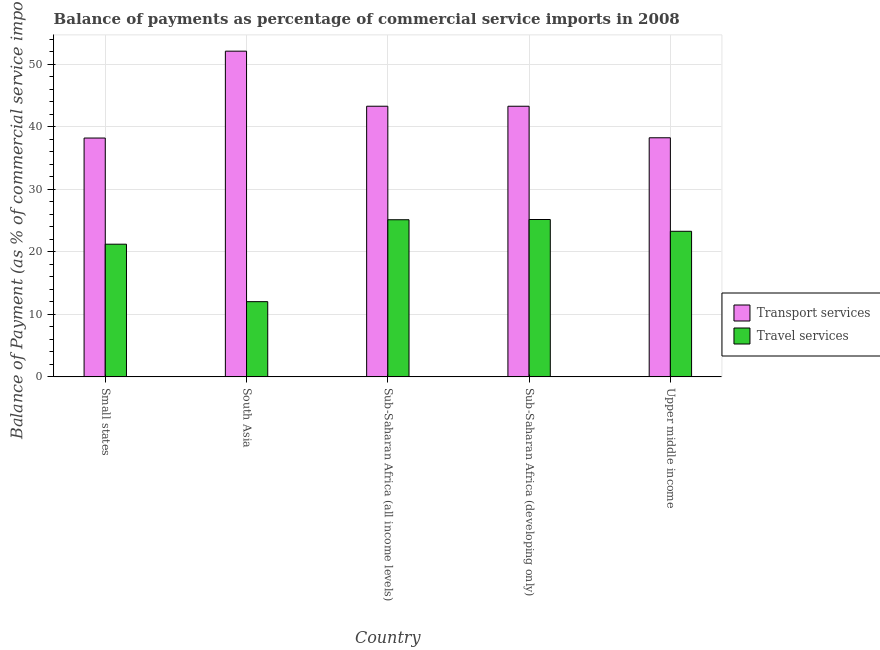How many different coloured bars are there?
Offer a terse response. 2. How many groups of bars are there?
Provide a succinct answer. 5. How many bars are there on the 1st tick from the left?
Provide a succinct answer. 2. What is the label of the 1st group of bars from the left?
Offer a very short reply. Small states. What is the balance of payments of travel services in Small states?
Your response must be concise. 21.23. Across all countries, what is the maximum balance of payments of transport services?
Your answer should be compact. 52.12. Across all countries, what is the minimum balance of payments of travel services?
Provide a short and direct response. 12.04. In which country was the balance of payments of transport services minimum?
Your answer should be very brief. Small states. What is the total balance of payments of travel services in the graph?
Ensure brevity in your answer.  106.89. What is the difference between the balance of payments of travel services in South Asia and that in Sub-Saharan Africa (all income levels)?
Offer a very short reply. -13.11. What is the difference between the balance of payments of travel services in Upper middle income and the balance of payments of transport services in South Asia?
Keep it short and to the point. -28.83. What is the average balance of payments of transport services per country?
Give a very brief answer. 43.04. What is the difference between the balance of payments of travel services and balance of payments of transport services in Sub-Saharan Africa (all income levels)?
Your response must be concise. -18.16. In how many countries, is the balance of payments of transport services greater than 30 %?
Give a very brief answer. 5. What is the ratio of the balance of payments of transport services in Sub-Saharan Africa (developing only) to that in Upper middle income?
Your answer should be very brief. 1.13. Is the difference between the balance of payments of travel services in South Asia and Sub-Saharan Africa (developing only) greater than the difference between the balance of payments of transport services in South Asia and Sub-Saharan Africa (developing only)?
Give a very brief answer. No. What is the difference between the highest and the second highest balance of payments of travel services?
Offer a very short reply. 0.04. What is the difference between the highest and the lowest balance of payments of travel services?
Provide a short and direct response. 13.15. In how many countries, is the balance of payments of transport services greater than the average balance of payments of transport services taken over all countries?
Give a very brief answer. 3. What does the 2nd bar from the left in Small states represents?
Provide a short and direct response. Travel services. What does the 2nd bar from the right in Sub-Saharan Africa (developing only) represents?
Keep it short and to the point. Transport services. Are all the bars in the graph horizontal?
Offer a very short reply. No. Are the values on the major ticks of Y-axis written in scientific E-notation?
Give a very brief answer. No. Does the graph contain any zero values?
Make the answer very short. No. Does the graph contain grids?
Keep it short and to the point. Yes. How many legend labels are there?
Provide a succinct answer. 2. What is the title of the graph?
Provide a succinct answer. Balance of payments as percentage of commercial service imports in 2008. What is the label or title of the X-axis?
Make the answer very short. Country. What is the label or title of the Y-axis?
Offer a very short reply. Balance of Payment (as % of commercial service imports). What is the Balance of Payment (as % of commercial service imports) of Transport services in Small states?
Your response must be concise. 38.22. What is the Balance of Payment (as % of commercial service imports) in Travel services in Small states?
Offer a very short reply. 21.23. What is the Balance of Payment (as % of commercial service imports) in Transport services in South Asia?
Your response must be concise. 52.12. What is the Balance of Payment (as % of commercial service imports) in Travel services in South Asia?
Offer a terse response. 12.04. What is the Balance of Payment (as % of commercial service imports) of Transport services in Sub-Saharan Africa (all income levels)?
Offer a terse response. 43.31. What is the Balance of Payment (as % of commercial service imports) in Travel services in Sub-Saharan Africa (all income levels)?
Provide a short and direct response. 25.15. What is the Balance of Payment (as % of commercial service imports) of Transport services in Sub-Saharan Africa (developing only)?
Your response must be concise. 43.31. What is the Balance of Payment (as % of commercial service imports) of Travel services in Sub-Saharan Africa (developing only)?
Your answer should be very brief. 25.18. What is the Balance of Payment (as % of commercial service imports) of Transport services in Upper middle income?
Your answer should be compact. 38.26. What is the Balance of Payment (as % of commercial service imports) in Travel services in Upper middle income?
Your response must be concise. 23.3. Across all countries, what is the maximum Balance of Payment (as % of commercial service imports) in Transport services?
Offer a terse response. 52.12. Across all countries, what is the maximum Balance of Payment (as % of commercial service imports) in Travel services?
Provide a succinct answer. 25.18. Across all countries, what is the minimum Balance of Payment (as % of commercial service imports) of Transport services?
Give a very brief answer. 38.22. Across all countries, what is the minimum Balance of Payment (as % of commercial service imports) in Travel services?
Make the answer very short. 12.04. What is the total Balance of Payment (as % of commercial service imports) in Transport services in the graph?
Give a very brief answer. 215.22. What is the total Balance of Payment (as % of commercial service imports) in Travel services in the graph?
Make the answer very short. 106.89. What is the difference between the Balance of Payment (as % of commercial service imports) of Transport services in Small states and that in South Asia?
Your answer should be compact. -13.9. What is the difference between the Balance of Payment (as % of commercial service imports) of Travel services in Small states and that in South Asia?
Provide a succinct answer. 9.2. What is the difference between the Balance of Payment (as % of commercial service imports) in Transport services in Small states and that in Sub-Saharan Africa (all income levels)?
Your answer should be very brief. -5.09. What is the difference between the Balance of Payment (as % of commercial service imports) of Travel services in Small states and that in Sub-Saharan Africa (all income levels)?
Your response must be concise. -3.91. What is the difference between the Balance of Payment (as % of commercial service imports) in Transport services in Small states and that in Sub-Saharan Africa (developing only)?
Provide a short and direct response. -5.09. What is the difference between the Balance of Payment (as % of commercial service imports) of Travel services in Small states and that in Sub-Saharan Africa (developing only)?
Ensure brevity in your answer.  -3.95. What is the difference between the Balance of Payment (as % of commercial service imports) of Transport services in Small states and that in Upper middle income?
Your response must be concise. -0.04. What is the difference between the Balance of Payment (as % of commercial service imports) of Travel services in Small states and that in Upper middle income?
Offer a very short reply. -2.06. What is the difference between the Balance of Payment (as % of commercial service imports) of Transport services in South Asia and that in Sub-Saharan Africa (all income levels)?
Your answer should be very brief. 8.81. What is the difference between the Balance of Payment (as % of commercial service imports) of Travel services in South Asia and that in Sub-Saharan Africa (all income levels)?
Offer a terse response. -13.11. What is the difference between the Balance of Payment (as % of commercial service imports) in Transport services in South Asia and that in Sub-Saharan Africa (developing only)?
Ensure brevity in your answer.  8.81. What is the difference between the Balance of Payment (as % of commercial service imports) of Travel services in South Asia and that in Sub-Saharan Africa (developing only)?
Provide a succinct answer. -13.15. What is the difference between the Balance of Payment (as % of commercial service imports) in Transport services in South Asia and that in Upper middle income?
Provide a succinct answer. 13.86. What is the difference between the Balance of Payment (as % of commercial service imports) of Travel services in South Asia and that in Upper middle income?
Keep it short and to the point. -11.26. What is the difference between the Balance of Payment (as % of commercial service imports) of Transport services in Sub-Saharan Africa (all income levels) and that in Sub-Saharan Africa (developing only)?
Make the answer very short. 0. What is the difference between the Balance of Payment (as % of commercial service imports) of Travel services in Sub-Saharan Africa (all income levels) and that in Sub-Saharan Africa (developing only)?
Offer a very short reply. -0.04. What is the difference between the Balance of Payment (as % of commercial service imports) of Transport services in Sub-Saharan Africa (all income levels) and that in Upper middle income?
Provide a short and direct response. 5.05. What is the difference between the Balance of Payment (as % of commercial service imports) in Travel services in Sub-Saharan Africa (all income levels) and that in Upper middle income?
Provide a succinct answer. 1.85. What is the difference between the Balance of Payment (as % of commercial service imports) in Transport services in Sub-Saharan Africa (developing only) and that in Upper middle income?
Your response must be concise. 5.05. What is the difference between the Balance of Payment (as % of commercial service imports) of Travel services in Sub-Saharan Africa (developing only) and that in Upper middle income?
Provide a short and direct response. 1.89. What is the difference between the Balance of Payment (as % of commercial service imports) of Transport services in Small states and the Balance of Payment (as % of commercial service imports) of Travel services in South Asia?
Your answer should be very brief. 26.18. What is the difference between the Balance of Payment (as % of commercial service imports) of Transport services in Small states and the Balance of Payment (as % of commercial service imports) of Travel services in Sub-Saharan Africa (all income levels)?
Make the answer very short. 13.07. What is the difference between the Balance of Payment (as % of commercial service imports) in Transport services in Small states and the Balance of Payment (as % of commercial service imports) in Travel services in Sub-Saharan Africa (developing only)?
Keep it short and to the point. 13.04. What is the difference between the Balance of Payment (as % of commercial service imports) in Transport services in Small states and the Balance of Payment (as % of commercial service imports) in Travel services in Upper middle income?
Offer a very short reply. 14.92. What is the difference between the Balance of Payment (as % of commercial service imports) in Transport services in South Asia and the Balance of Payment (as % of commercial service imports) in Travel services in Sub-Saharan Africa (all income levels)?
Make the answer very short. 26.98. What is the difference between the Balance of Payment (as % of commercial service imports) of Transport services in South Asia and the Balance of Payment (as % of commercial service imports) of Travel services in Sub-Saharan Africa (developing only)?
Your response must be concise. 26.94. What is the difference between the Balance of Payment (as % of commercial service imports) in Transport services in South Asia and the Balance of Payment (as % of commercial service imports) in Travel services in Upper middle income?
Give a very brief answer. 28.83. What is the difference between the Balance of Payment (as % of commercial service imports) of Transport services in Sub-Saharan Africa (all income levels) and the Balance of Payment (as % of commercial service imports) of Travel services in Sub-Saharan Africa (developing only)?
Your response must be concise. 18.13. What is the difference between the Balance of Payment (as % of commercial service imports) of Transport services in Sub-Saharan Africa (all income levels) and the Balance of Payment (as % of commercial service imports) of Travel services in Upper middle income?
Keep it short and to the point. 20.01. What is the difference between the Balance of Payment (as % of commercial service imports) in Transport services in Sub-Saharan Africa (developing only) and the Balance of Payment (as % of commercial service imports) in Travel services in Upper middle income?
Keep it short and to the point. 20.01. What is the average Balance of Payment (as % of commercial service imports) of Transport services per country?
Your response must be concise. 43.04. What is the average Balance of Payment (as % of commercial service imports) of Travel services per country?
Ensure brevity in your answer.  21.38. What is the difference between the Balance of Payment (as % of commercial service imports) of Transport services and Balance of Payment (as % of commercial service imports) of Travel services in Small states?
Give a very brief answer. 16.99. What is the difference between the Balance of Payment (as % of commercial service imports) in Transport services and Balance of Payment (as % of commercial service imports) in Travel services in South Asia?
Offer a very short reply. 40.09. What is the difference between the Balance of Payment (as % of commercial service imports) of Transport services and Balance of Payment (as % of commercial service imports) of Travel services in Sub-Saharan Africa (all income levels)?
Provide a succinct answer. 18.16. What is the difference between the Balance of Payment (as % of commercial service imports) in Transport services and Balance of Payment (as % of commercial service imports) in Travel services in Sub-Saharan Africa (developing only)?
Ensure brevity in your answer.  18.12. What is the difference between the Balance of Payment (as % of commercial service imports) of Transport services and Balance of Payment (as % of commercial service imports) of Travel services in Upper middle income?
Your answer should be compact. 14.96. What is the ratio of the Balance of Payment (as % of commercial service imports) of Transport services in Small states to that in South Asia?
Offer a very short reply. 0.73. What is the ratio of the Balance of Payment (as % of commercial service imports) in Travel services in Small states to that in South Asia?
Your response must be concise. 1.76. What is the ratio of the Balance of Payment (as % of commercial service imports) of Transport services in Small states to that in Sub-Saharan Africa (all income levels)?
Give a very brief answer. 0.88. What is the ratio of the Balance of Payment (as % of commercial service imports) in Travel services in Small states to that in Sub-Saharan Africa (all income levels)?
Provide a succinct answer. 0.84. What is the ratio of the Balance of Payment (as % of commercial service imports) of Transport services in Small states to that in Sub-Saharan Africa (developing only)?
Offer a very short reply. 0.88. What is the ratio of the Balance of Payment (as % of commercial service imports) in Travel services in Small states to that in Sub-Saharan Africa (developing only)?
Give a very brief answer. 0.84. What is the ratio of the Balance of Payment (as % of commercial service imports) in Travel services in Small states to that in Upper middle income?
Your answer should be very brief. 0.91. What is the ratio of the Balance of Payment (as % of commercial service imports) in Transport services in South Asia to that in Sub-Saharan Africa (all income levels)?
Offer a very short reply. 1.2. What is the ratio of the Balance of Payment (as % of commercial service imports) in Travel services in South Asia to that in Sub-Saharan Africa (all income levels)?
Keep it short and to the point. 0.48. What is the ratio of the Balance of Payment (as % of commercial service imports) of Transport services in South Asia to that in Sub-Saharan Africa (developing only)?
Your answer should be very brief. 1.2. What is the ratio of the Balance of Payment (as % of commercial service imports) in Travel services in South Asia to that in Sub-Saharan Africa (developing only)?
Keep it short and to the point. 0.48. What is the ratio of the Balance of Payment (as % of commercial service imports) of Transport services in South Asia to that in Upper middle income?
Ensure brevity in your answer.  1.36. What is the ratio of the Balance of Payment (as % of commercial service imports) of Travel services in South Asia to that in Upper middle income?
Offer a terse response. 0.52. What is the ratio of the Balance of Payment (as % of commercial service imports) of Transport services in Sub-Saharan Africa (all income levels) to that in Upper middle income?
Provide a short and direct response. 1.13. What is the ratio of the Balance of Payment (as % of commercial service imports) of Travel services in Sub-Saharan Africa (all income levels) to that in Upper middle income?
Offer a very short reply. 1.08. What is the ratio of the Balance of Payment (as % of commercial service imports) in Transport services in Sub-Saharan Africa (developing only) to that in Upper middle income?
Your response must be concise. 1.13. What is the ratio of the Balance of Payment (as % of commercial service imports) in Travel services in Sub-Saharan Africa (developing only) to that in Upper middle income?
Make the answer very short. 1.08. What is the difference between the highest and the second highest Balance of Payment (as % of commercial service imports) of Transport services?
Make the answer very short. 8.81. What is the difference between the highest and the second highest Balance of Payment (as % of commercial service imports) in Travel services?
Ensure brevity in your answer.  0.04. What is the difference between the highest and the lowest Balance of Payment (as % of commercial service imports) in Transport services?
Offer a terse response. 13.9. What is the difference between the highest and the lowest Balance of Payment (as % of commercial service imports) in Travel services?
Offer a terse response. 13.15. 